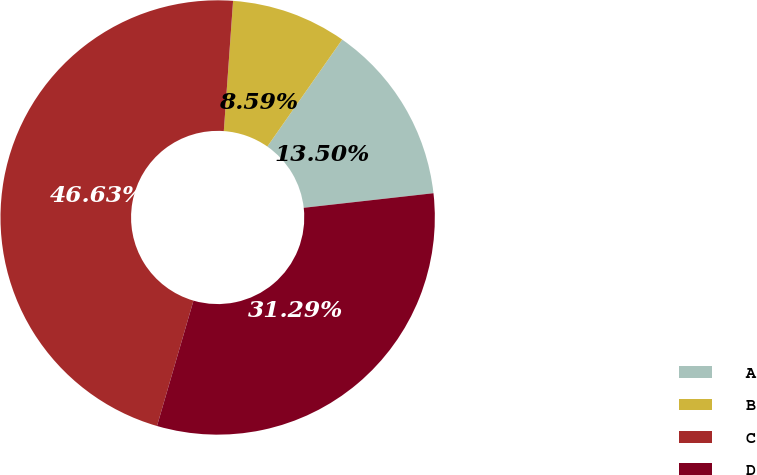Convert chart. <chart><loc_0><loc_0><loc_500><loc_500><pie_chart><fcel>A<fcel>B<fcel>C<fcel>D<nl><fcel>13.5%<fcel>8.59%<fcel>46.63%<fcel>31.29%<nl></chart> 